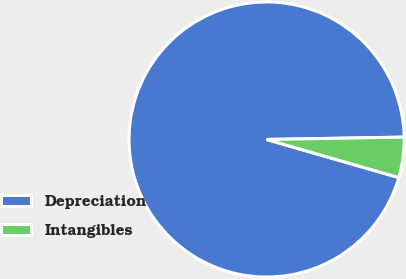<chart> <loc_0><loc_0><loc_500><loc_500><pie_chart><fcel>Depreciation<fcel>Intangibles<nl><fcel>95.26%<fcel>4.74%<nl></chart> 